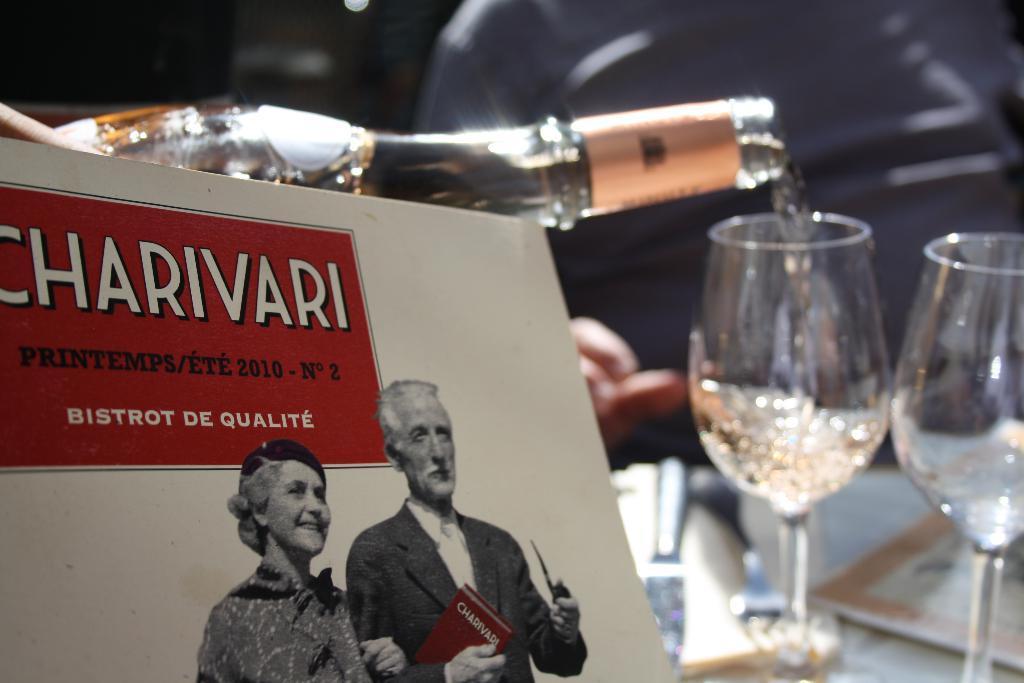Please provide a concise description of this image. In this image I see a woman and a man on a paper and I see bottle and 2 glasses. 